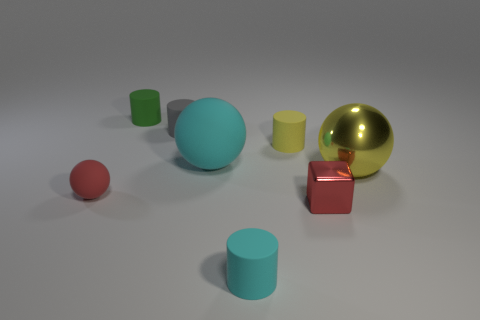Subtract all tiny gray cylinders. How many cylinders are left? 3 Add 2 big blue metallic cylinders. How many objects exist? 10 Subtract all yellow spheres. How many spheres are left? 2 Subtract all balls. How many objects are left? 5 Subtract 2 balls. How many balls are left? 1 Add 5 cyan cylinders. How many cyan cylinders exist? 6 Subtract 1 yellow cylinders. How many objects are left? 7 Subtract all brown balls. Subtract all gray cubes. How many balls are left? 3 Subtract all red cylinders. How many yellow spheres are left? 1 Subtract all yellow cylinders. Subtract all green cylinders. How many objects are left? 6 